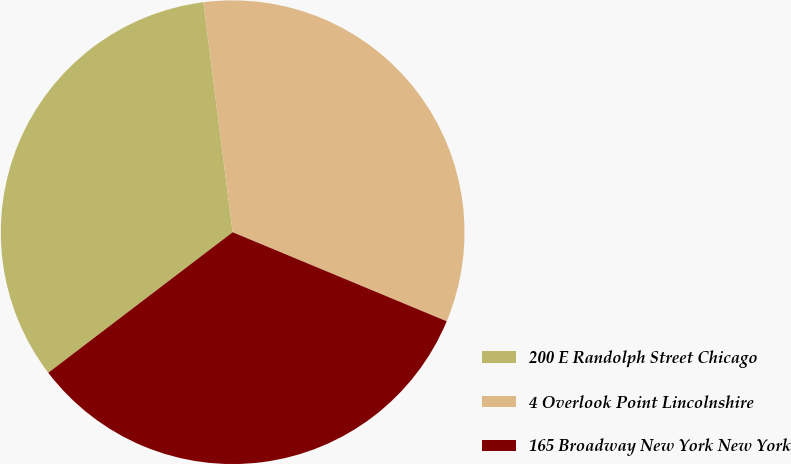Convert chart. <chart><loc_0><loc_0><loc_500><loc_500><pie_chart><fcel>200 E Randolph Street Chicago<fcel>4 Overlook Point Lincolnshire<fcel>165 Broadway New York New York<nl><fcel>33.35%<fcel>33.29%<fcel>33.36%<nl></chart> 